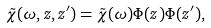<formula> <loc_0><loc_0><loc_500><loc_500>\tilde { \chi } ( \omega , z , z ^ { \prime } ) = \tilde { \chi } ( \omega ) \Phi ( z ) \Phi ( z ^ { \prime } ) ,</formula> 